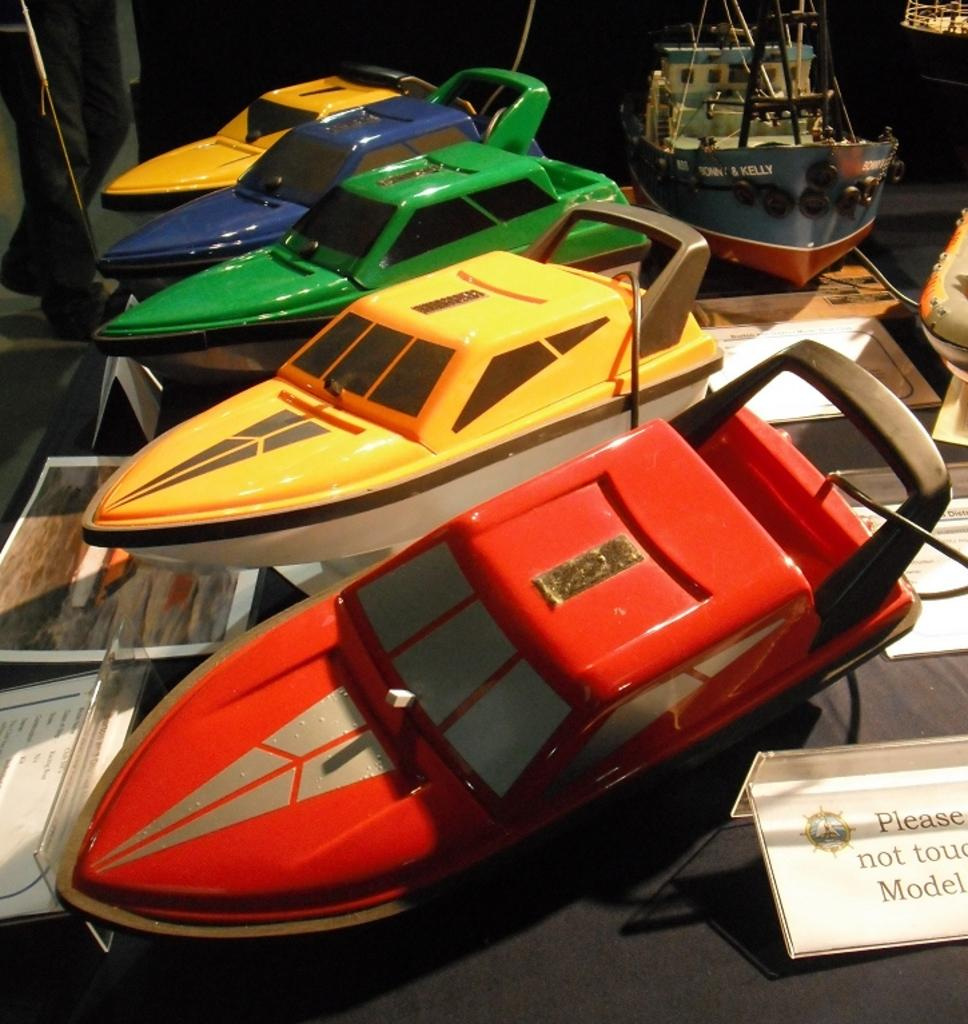What type of models are present in the image? There are model boats and model ships in the image. Can you describe the appearance of the models? The model boats and ships have different colors. How many steps are required to sort the model boats and ships by color in the image? There is no sorting or steps involved in the image, as it only shows model boats and ships with different colors. 